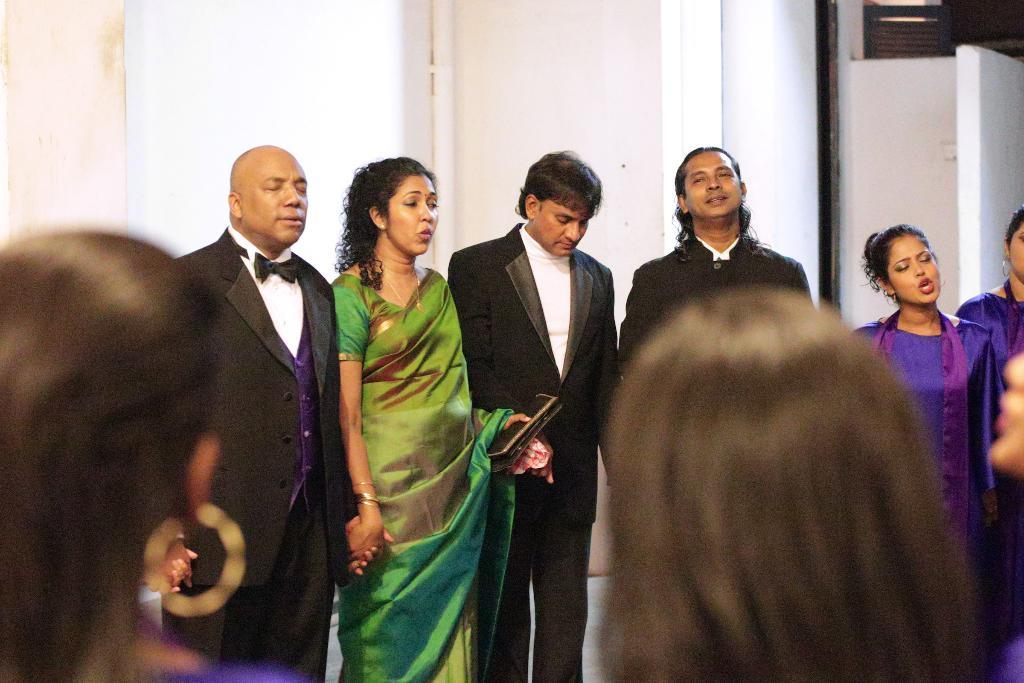What is happening in the image? There is a group of people standing in the image. What can be seen in the background of the image? There is a wall in the image. What is the color of the wall? The wall is white in color. What type of loaf is being sliced on the table in the image? There is no table or loaf present in the image; it only features a group of people standing and a white wall in the background. 